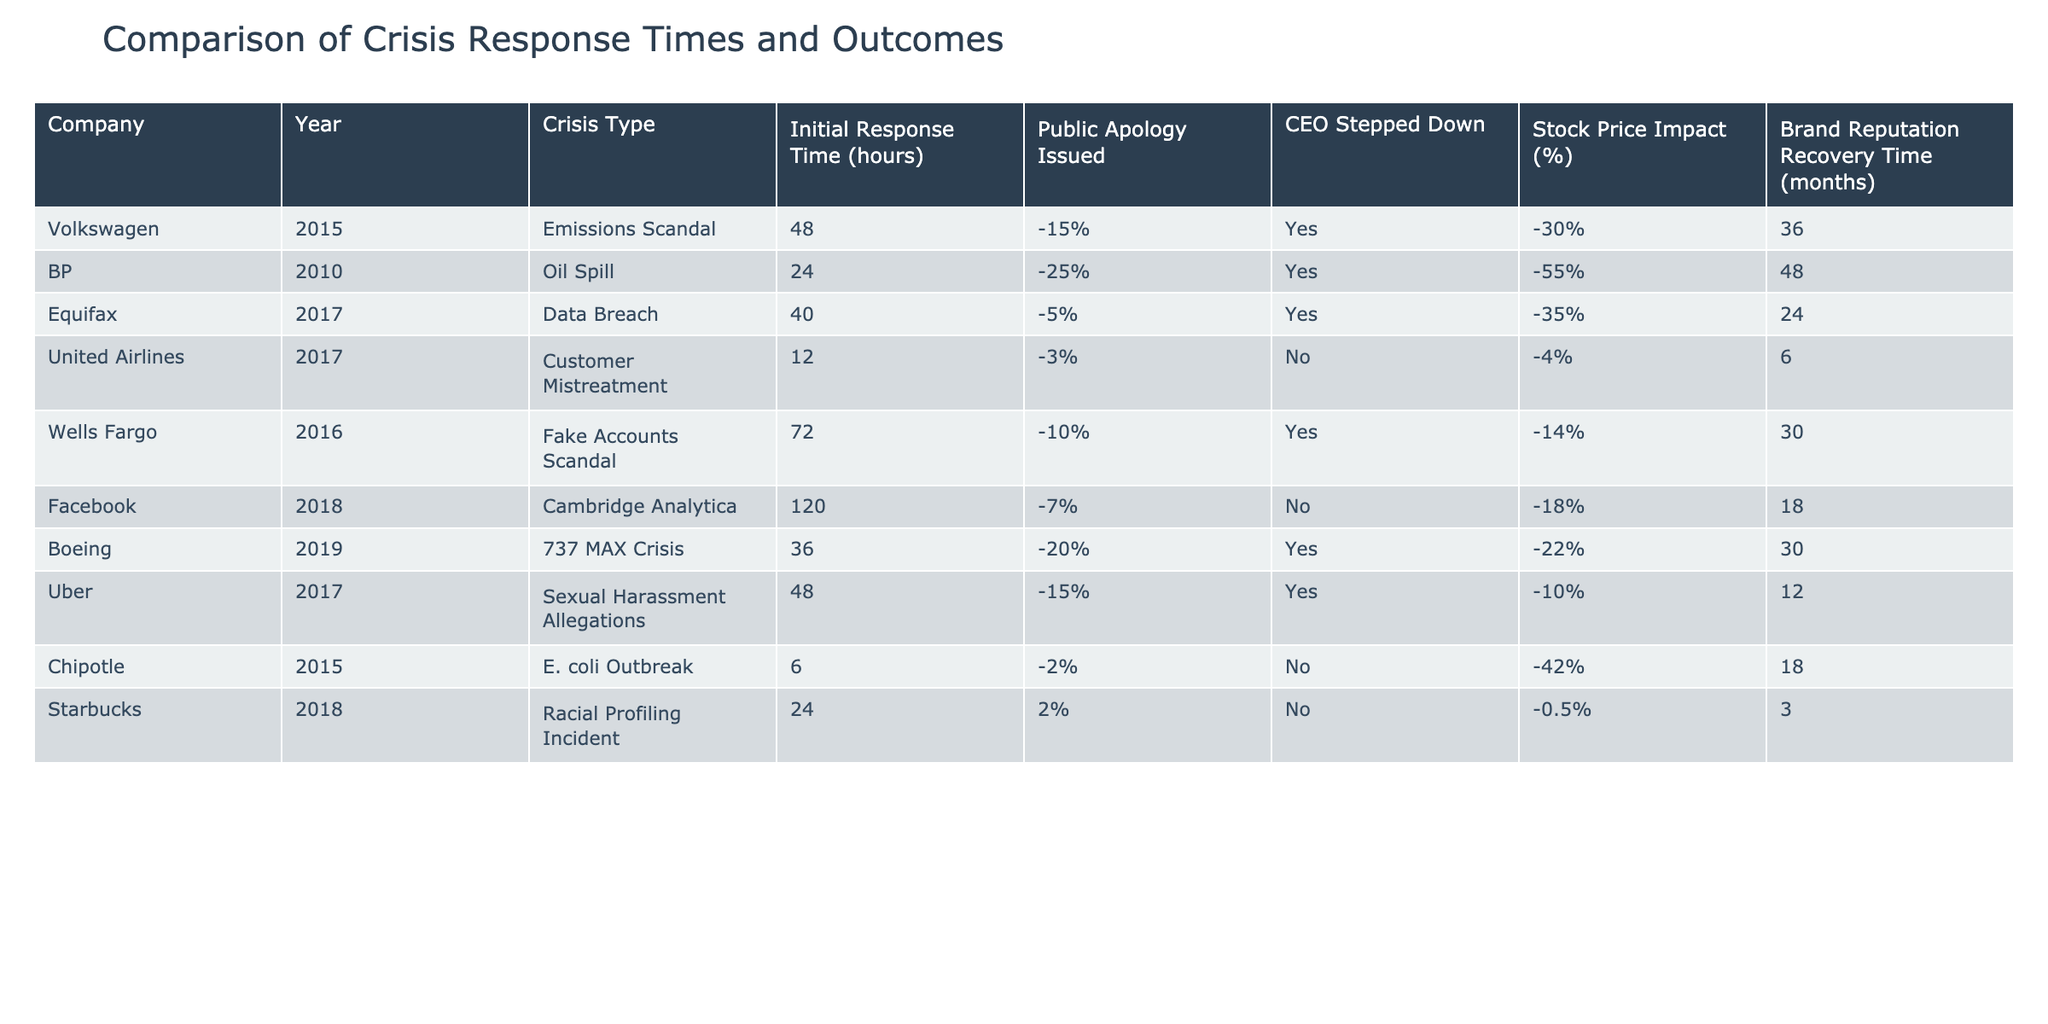What was the initial response time for the BP oil spill crisis? Looking at the table, the initial response time listed for BP during the oil spill in 2010 is 24 hours.
Answer: 24 hours Which company had the longest brand reputation recovery time? By comparing the brand reputation recovery times listed in the table, Wells Fargo has the longest recovery time of 30 months.
Answer: 30 months Did United Airlines issue a public apology during their crisis in 2017? According to the table, United Airlines did not issue a public apology during their customer mistreatment crisis.
Answer: No What is the average stock price impact for companies that did not have their CEO step down? We look at companies that did not have their CEO step down, which are United Airlines and Starbucks. Their stock price impacts are -4% and -0.5%, respectively. Summing those gives us -4% + (-0.5%) = -4.5%. Dividing by 2 (the number of companies) gives an average of -2.25%.
Answer: -2.25% Which crisis had the highest stock price impact? From the table, BP's oil spill crisis has the highest stock price impact at -55%.
Answer: -55% How many companies stepped down their CEOs out of those listed? By checking the table, four companies had their CEOs step down: BP, Equifax, Wells Fargo, and Boeing, leading us to conclude that 4 companies made this decision.
Answer: 4 companies What was the public apology issued by Volkswagen in terms of percentage? According to the table, Volkswagen issued a public apology that had a stock price impact of -15%.
Answer: -15% Which company had the shortest initial response time, and what was it? From the data, Chipotle had the shortest initial response time, which was 6 hours.
Answer: 6 hours Was there a positive public apology percentage from Starbucks, and what was it? The table shows that Starbucks had a public apology which positively impacted stock prices by 2%.
Answer: Yes, 2% 